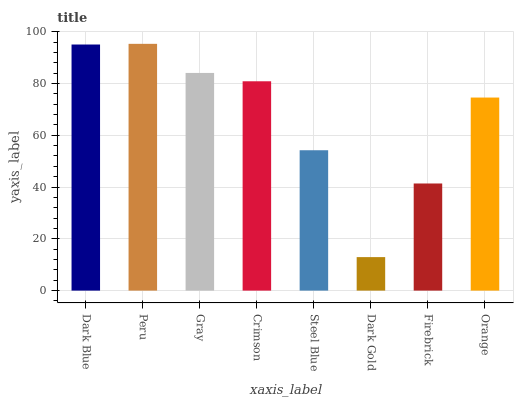Is Dark Gold the minimum?
Answer yes or no. Yes. Is Peru the maximum?
Answer yes or no. Yes. Is Gray the minimum?
Answer yes or no. No. Is Gray the maximum?
Answer yes or no. No. Is Peru greater than Gray?
Answer yes or no. Yes. Is Gray less than Peru?
Answer yes or no. Yes. Is Gray greater than Peru?
Answer yes or no. No. Is Peru less than Gray?
Answer yes or no. No. Is Crimson the high median?
Answer yes or no. Yes. Is Orange the low median?
Answer yes or no. Yes. Is Steel Blue the high median?
Answer yes or no. No. Is Steel Blue the low median?
Answer yes or no. No. 